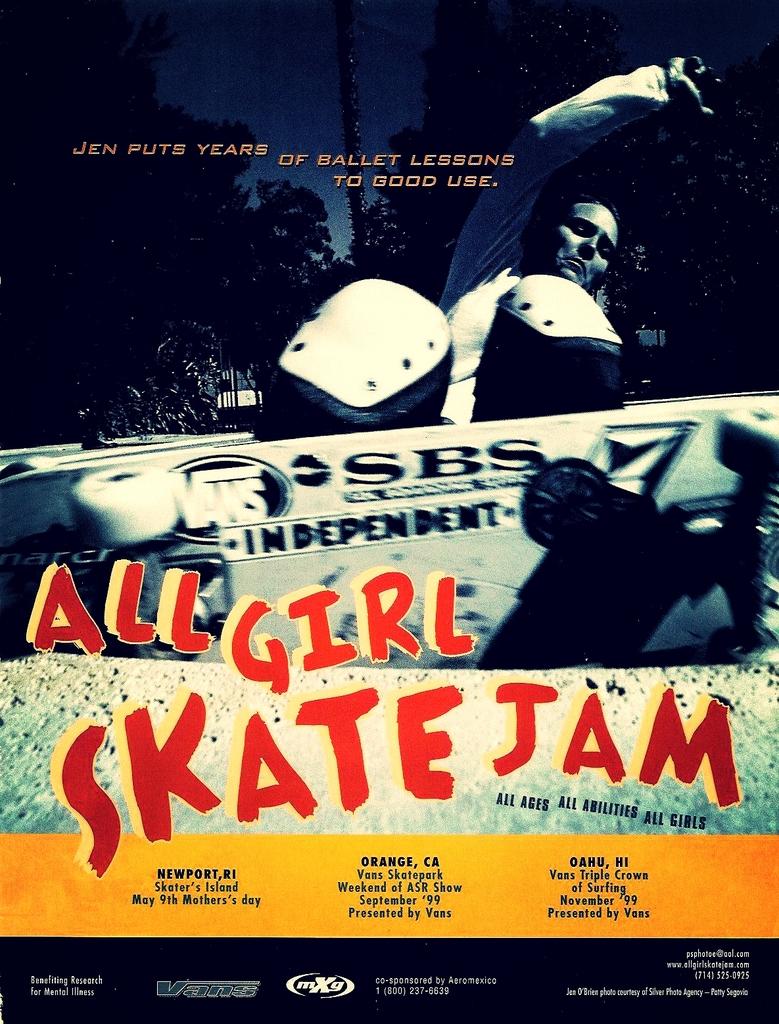Is this a movie?
Your answer should be very brief. Yes. What is the name of the film?
Your response must be concise. All girl skate jam. 